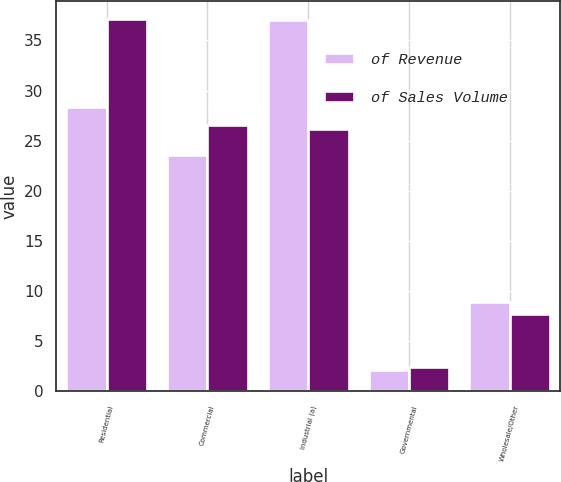Convert chart to OTSL. <chart><loc_0><loc_0><loc_500><loc_500><stacked_bar_chart><ecel><fcel>Residential<fcel>Commercial<fcel>Industrial (a)<fcel>Governmental<fcel>Wholesale/Other<nl><fcel>of Revenue<fcel>28.4<fcel>23.6<fcel>37<fcel>2.1<fcel>8.9<nl><fcel>of Sales Volume<fcel>37.1<fcel>26.6<fcel>26.2<fcel>2.4<fcel>7.7<nl></chart> 